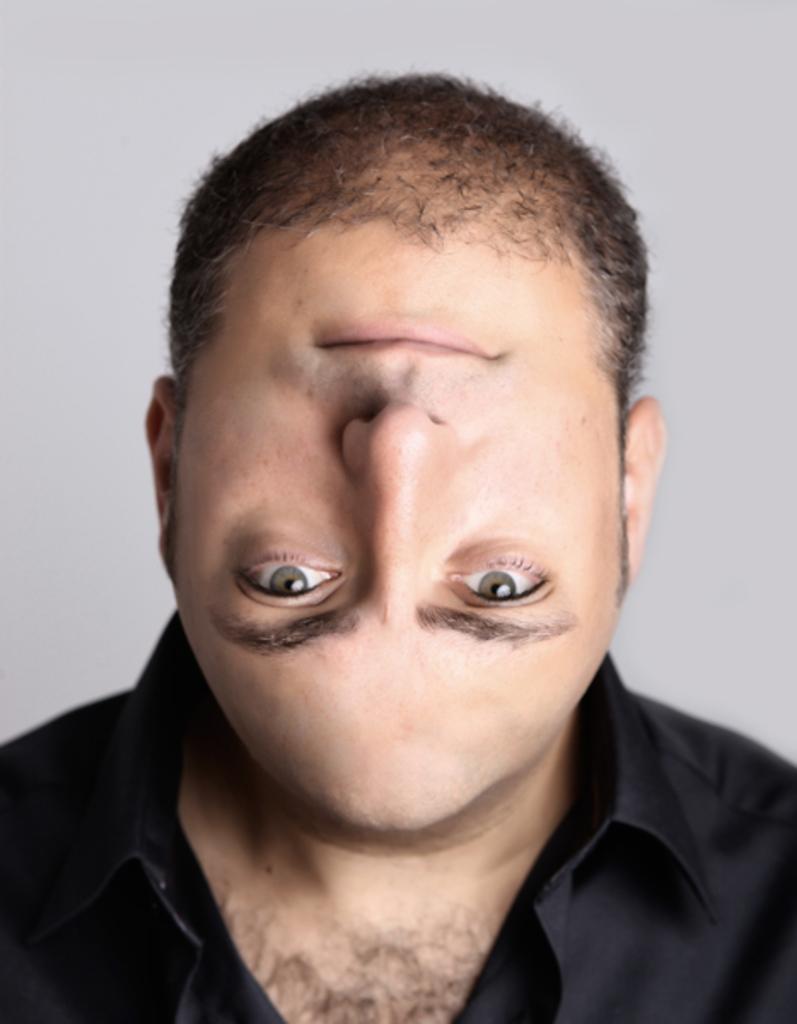Describe this image in one or two sentences. In this picture we can see a person having reverse head. 